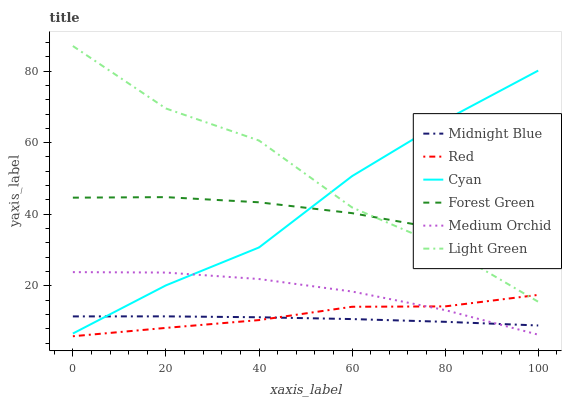Does Midnight Blue have the minimum area under the curve?
Answer yes or no. Yes. Does Light Green have the maximum area under the curve?
Answer yes or no. Yes. Does Medium Orchid have the minimum area under the curve?
Answer yes or no. No. Does Medium Orchid have the maximum area under the curve?
Answer yes or no. No. Is Midnight Blue the smoothest?
Answer yes or no. Yes. Is Light Green the roughest?
Answer yes or no. Yes. Is Medium Orchid the smoothest?
Answer yes or no. No. Is Medium Orchid the roughest?
Answer yes or no. No. Does Red have the lowest value?
Answer yes or no. Yes. Does Medium Orchid have the lowest value?
Answer yes or no. No. Does Light Green have the highest value?
Answer yes or no. Yes. Does Medium Orchid have the highest value?
Answer yes or no. No. Is Red less than Cyan?
Answer yes or no. Yes. Is Light Green greater than Midnight Blue?
Answer yes or no. Yes. Does Midnight Blue intersect Cyan?
Answer yes or no. Yes. Is Midnight Blue less than Cyan?
Answer yes or no. No. Is Midnight Blue greater than Cyan?
Answer yes or no. No. Does Red intersect Cyan?
Answer yes or no. No. 